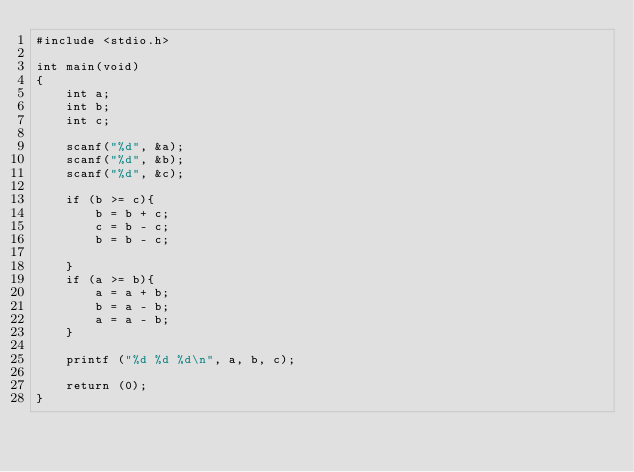Convert code to text. <code><loc_0><loc_0><loc_500><loc_500><_C_>#include <stdio.h>

int main(void)
{
	int a;
	int b;
	int c;
	
	scanf("%d", &a);
	scanf("%d", &b);
	scanf("%d", &c);
	
	if (b >= c){
		b = b + c;
		c = b - c;
		b = b - c;
		
	}
	if (a >= b){
		a = a + b;
		b = a - b;
		a = a - b;
	}
		
	printf ("%d %d %d\n", a, b, c);
	
	return (0);
}</code> 